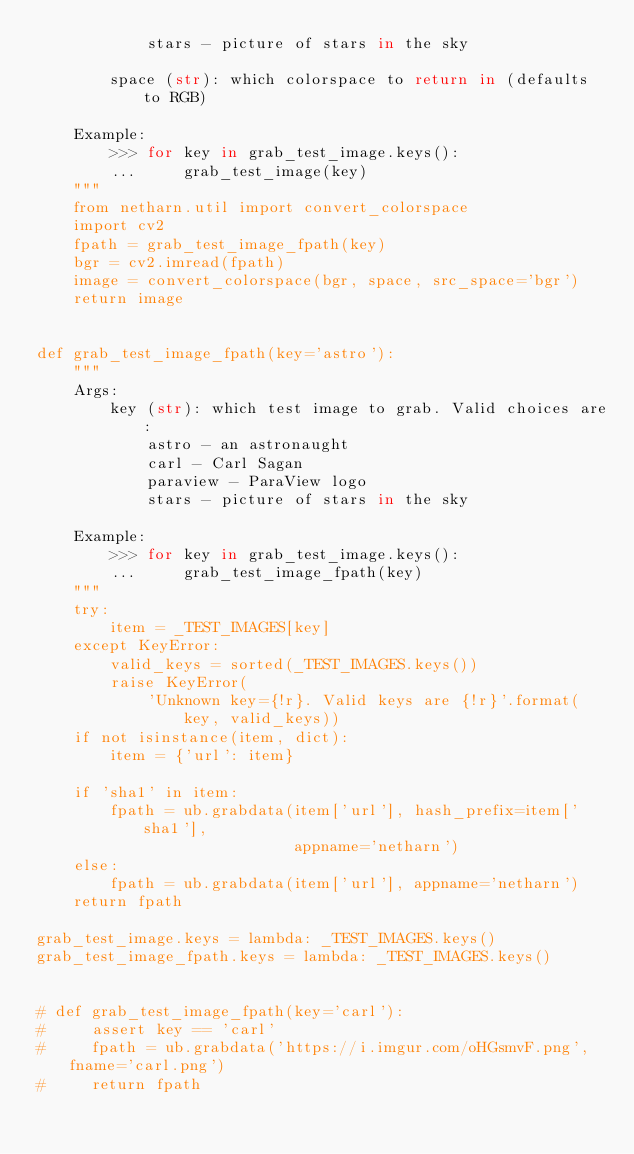<code> <loc_0><loc_0><loc_500><loc_500><_Python_>            stars - picture of stars in the sky

        space (str): which colorspace to return in (defaults to RGB)

    Example:
        >>> for key in grab_test_image.keys():
        ...     grab_test_image(key)
    """
    from netharn.util import convert_colorspace
    import cv2
    fpath = grab_test_image_fpath(key)
    bgr = cv2.imread(fpath)
    image = convert_colorspace(bgr, space, src_space='bgr')
    return image


def grab_test_image_fpath(key='astro'):
    """
    Args:
        key (str): which test image to grab. Valid choices are:
            astro - an astronaught
            carl - Carl Sagan
            paraview - ParaView logo
            stars - picture of stars in the sky

    Example:
        >>> for key in grab_test_image.keys():
        ...     grab_test_image_fpath(key)
    """
    try:
        item = _TEST_IMAGES[key]
    except KeyError:
        valid_keys = sorted(_TEST_IMAGES.keys())
        raise KeyError(
            'Unknown key={!r}. Valid keys are {!r}'.format(
                key, valid_keys))
    if not isinstance(item, dict):
        item = {'url': item}

    if 'sha1' in item:
        fpath = ub.grabdata(item['url'], hash_prefix=item['sha1'],
                            appname='netharn')
    else:
        fpath = ub.grabdata(item['url'], appname='netharn')
    return fpath

grab_test_image.keys = lambda: _TEST_IMAGES.keys()
grab_test_image_fpath.keys = lambda: _TEST_IMAGES.keys()


# def grab_test_image_fpath(key='carl'):
#     assert key == 'carl'
#     fpath = ub.grabdata('https://i.imgur.com/oHGsmvF.png', fname='carl.png')
#     return fpath
</code> 